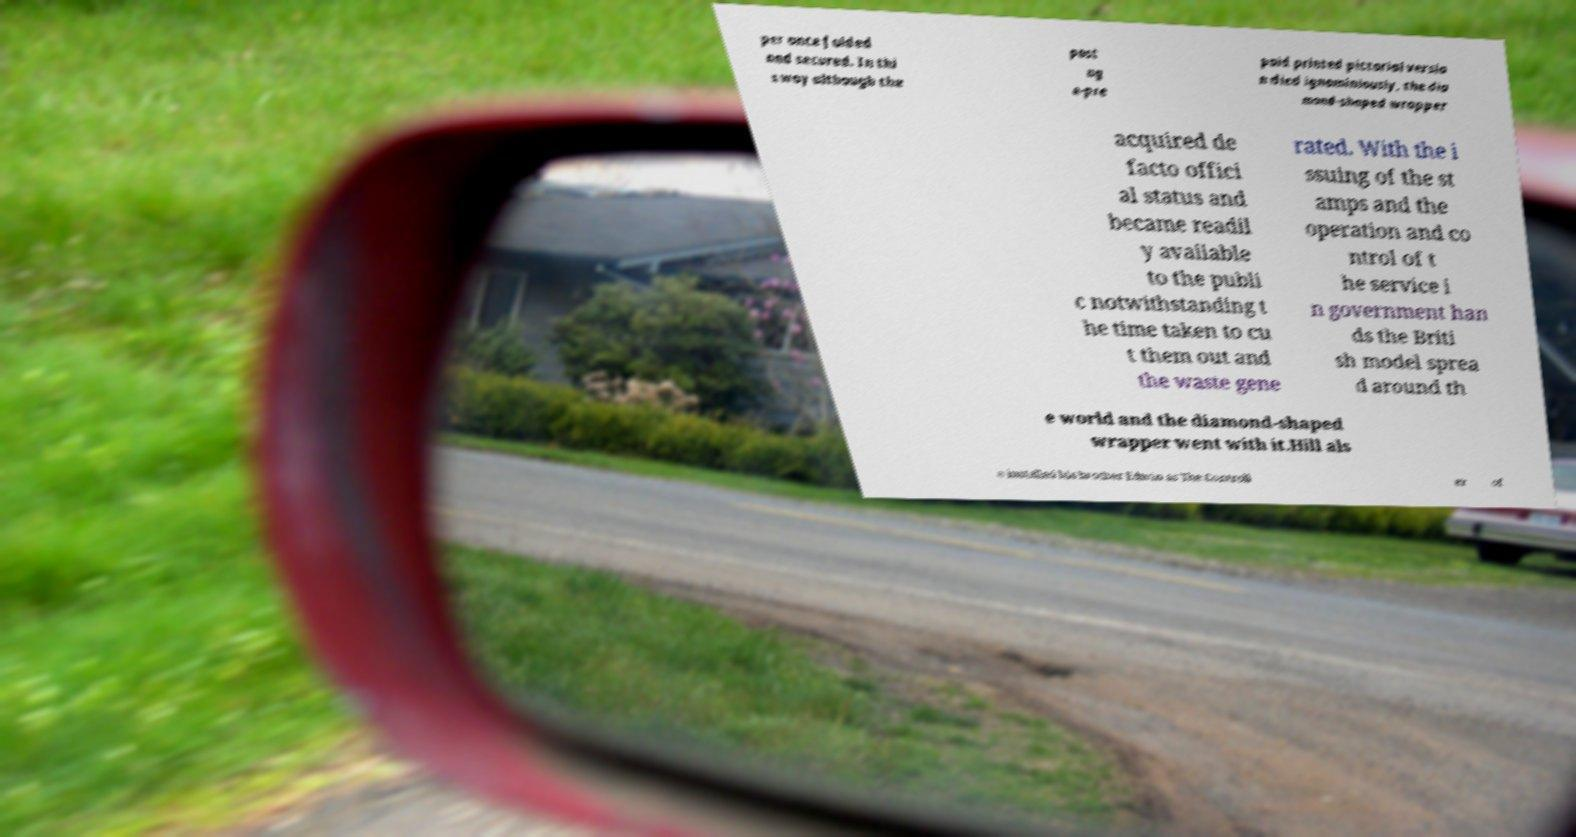I need the written content from this picture converted into text. Can you do that? per once folded and secured. In thi s way although the post ag e-pre paid printed pictorial versio n died ignominiously, the dia mond-shaped wrapper acquired de facto offici al status and became readil y available to the publi c notwithstanding t he time taken to cu t them out and the waste gene rated. With the i ssuing of the st amps and the operation and co ntrol of t he service i n government han ds the Briti sh model sprea d around th e world and the diamond-shaped wrapper went with it.Hill als o installed his brother Edwin as The Controll er of 